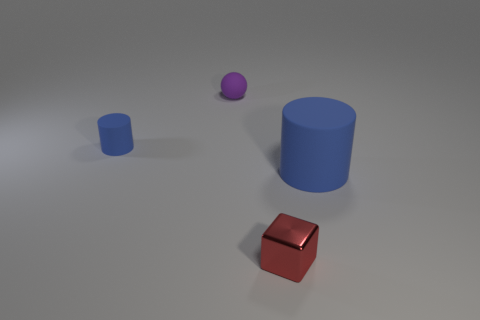Are there more large brown rubber cubes than small rubber spheres? no 